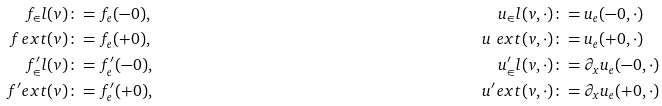Convert formula to latex. <formula><loc_0><loc_0><loc_500><loc_500>f _ { \in } l ( v ) & \colon = f _ { e } ( - 0 ) , & u _ { \in } l ( v , \cdot ) & \colon = u _ { e } ( - 0 , \cdot ) \\ f _ { \ } e x t ( v ) & \colon = f _ { e } ( + 0 ) , & u _ { \ } e x t ( v , \cdot ) & \colon = u _ { e } ( + 0 , \cdot ) \\ f ^ { \prime } _ { \in } l ( v ) & \colon = f ^ { \prime } _ { e } ( - 0 ) , & u ^ { \prime } _ { \in } l ( v , \cdot ) & \colon = \partial _ { x } u _ { e } ( - 0 , \cdot ) \\ f ^ { \prime } _ { \ } e x t ( v ) & \colon = f ^ { \prime } _ { e } ( + 0 ) , & u ^ { \prime } _ { \ } e x t ( v , \cdot ) & \colon = \partial _ { x } u _ { e } ( + 0 , \cdot )</formula> 